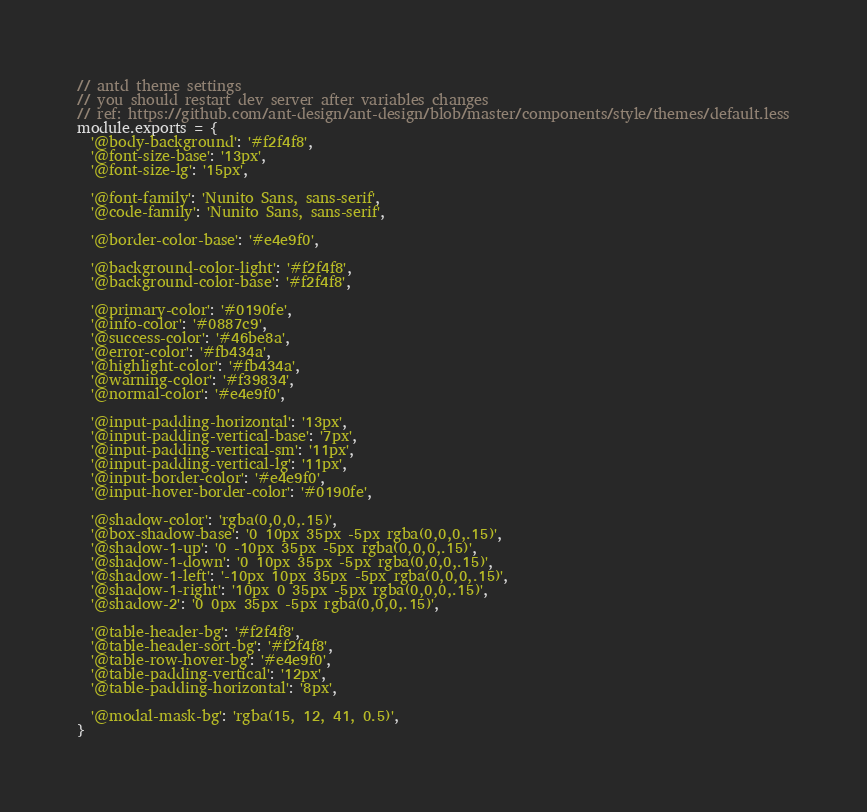<code> <loc_0><loc_0><loc_500><loc_500><_JavaScript_>// antd theme settings
// you should restart dev server after variables changes
// ref: https://github.com/ant-design/ant-design/blob/master/components/style/themes/default.less
module.exports = {
  '@body-background': '#f2f4f8',
  '@font-size-base': '13px',
  '@font-size-lg': '15px',

  '@font-family': 'Nunito Sans, sans-serif',
  '@code-family': 'Nunito Sans, sans-serif',

  '@border-color-base': '#e4e9f0',

  '@background-color-light': '#f2f4f8',
  '@background-color-base': '#f2f4f8',

  '@primary-color': '#0190fe',
  '@info-color': '#0887c9',
  '@success-color': '#46be8a',
  '@error-color': '#fb434a',
  '@highlight-color': '#fb434a',
  '@warning-color': '#f39834',
  '@normal-color': '#e4e9f0',

  '@input-padding-horizontal': '13px',
  '@input-padding-vertical-base': '7px',
  '@input-padding-vertical-sm': '11px',
  '@input-padding-vertical-lg': '11px',
  '@input-border-color': '#e4e9f0',
  '@input-hover-border-color': '#0190fe',

  '@shadow-color': 'rgba(0,0,0,.15)',
  '@box-shadow-base': '0 10px 35px -5px rgba(0,0,0,.15)',
  '@shadow-1-up': '0 -10px 35px -5px rgba(0,0,0,.15)',
  '@shadow-1-down': '0 10px 35px -5px rgba(0,0,0,.15)',
  '@shadow-1-left': '-10px 10px 35px -5px rgba(0,0,0,.15)',
  '@shadow-1-right': '10px 0 35px -5px rgba(0,0,0,.15)',
  '@shadow-2': '0 0px 35px -5px rgba(0,0,0,.15)',

  '@table-header-bg': '#f2f4f8',
  '@table-header-sort-bg': '#f2f4f8',
  '@table-row-hover-bg': '#e4e9f0',
  '@table-padding-vertical': '12px',
  '@table-padding-horizontal': '8px',

  '@modal-mask-bg': 'rgba(15, 12, 41, 0.5)',
}
</code> 